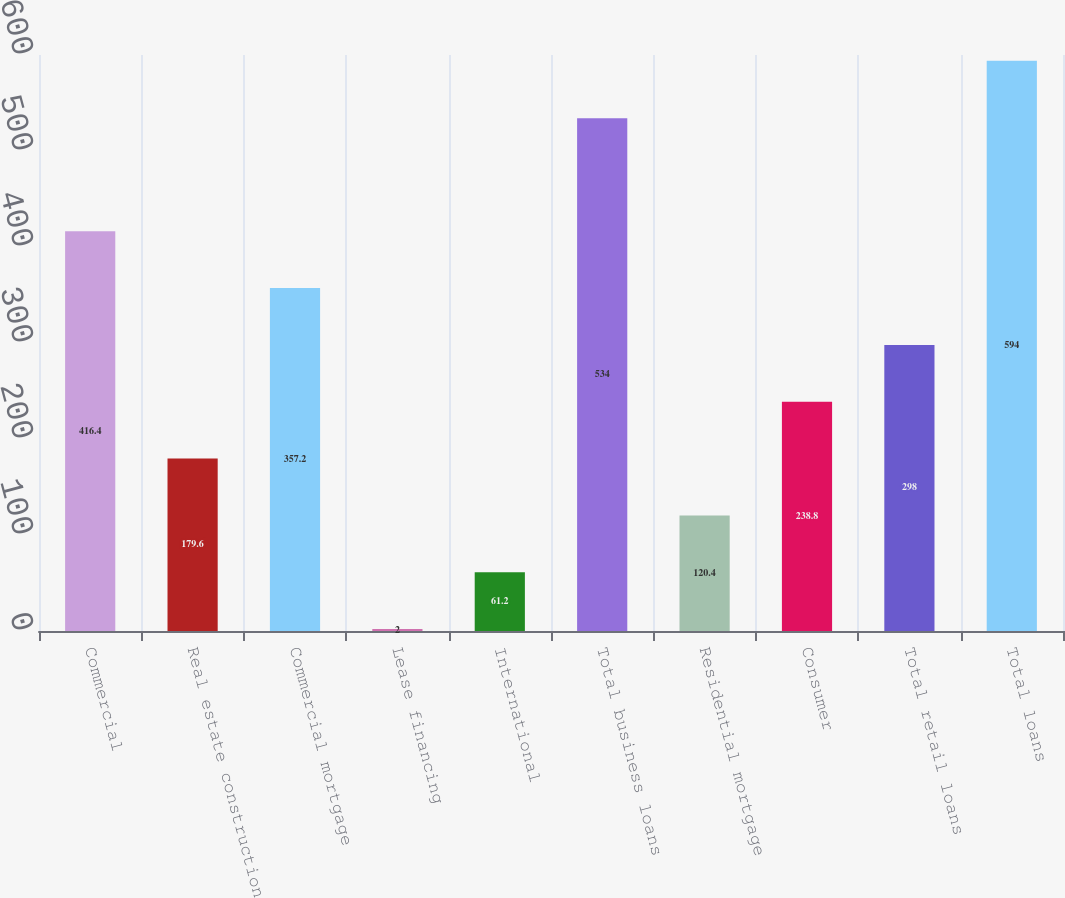Convert chart to OTSL. <chart><loc_0><loc_0><loc_500><loc_500><bar_chart><fcel>Commercial<fcel>Real estate construction<fcel>Commercial mortgage<fcel>Lease financing<fcel>International<fcel>Total business loans<fcel>Residential mortgage<fcel>Consumer<fcel>Total retail loans<fcel>Total loans<nl><fcel>416.4<fcel>179.6<fcel>357.2<fcel>2<fcel>61.2<fcel>534<fcel>120.4<fcel>238.8<fcel>298<fcel>594<nl></chart> 